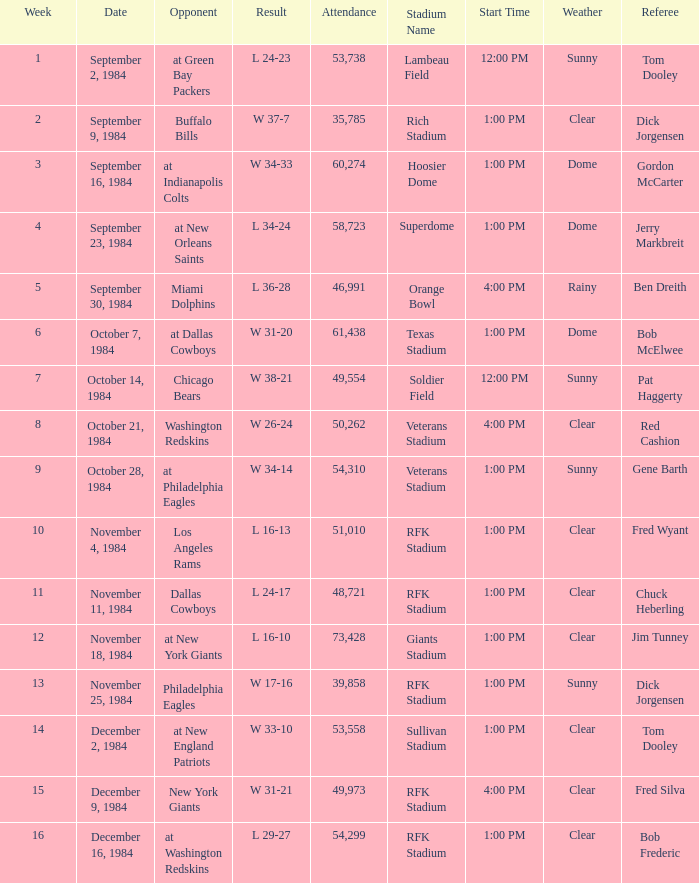What is the sum of attendance when the result was l 16-13? 51010.0. 